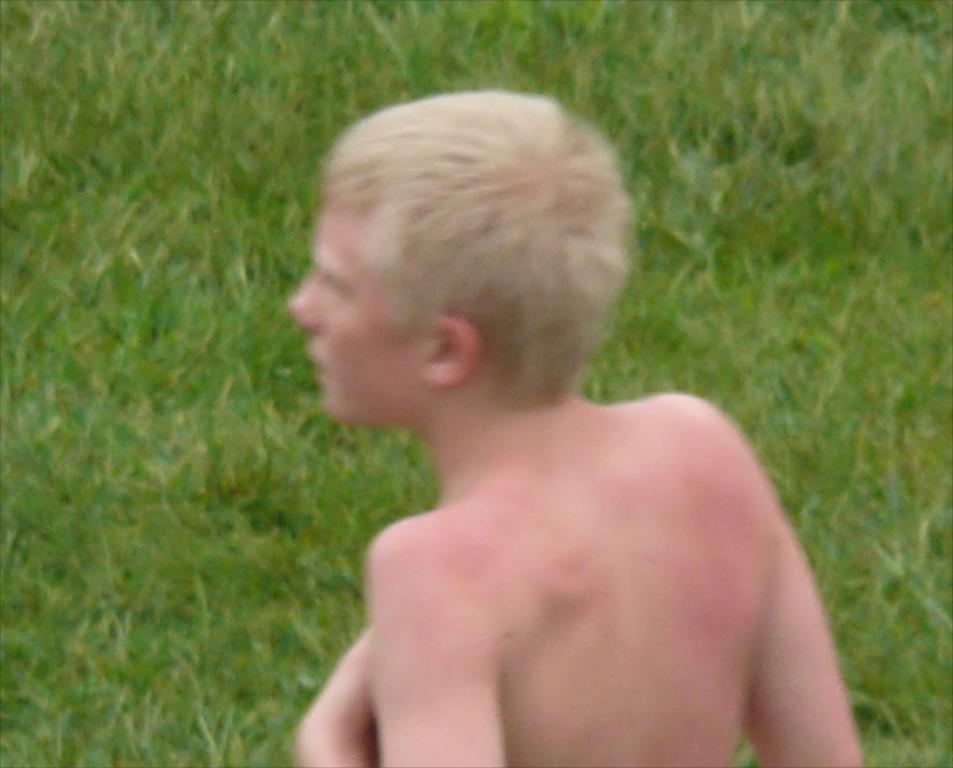Who is the main subject in the image? There is a boy in the center of the image. What type of environment is depicted in the image? There is grassland in the image. What type of pen can be seen in the boy's hand in the image? There is no pen visible in the boy's hand in the image. 